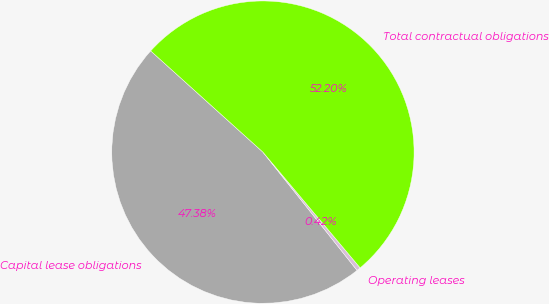<chart> <loc_0><loc_0><loc_500><loc_500><pie_chart><fcel>Capital lease obligations<fcel>Operating leases<fcel>Total contractual obligations<nl><fcel>47.38%<fcel>0.42%<fcel>52.2%<nl></chart> 